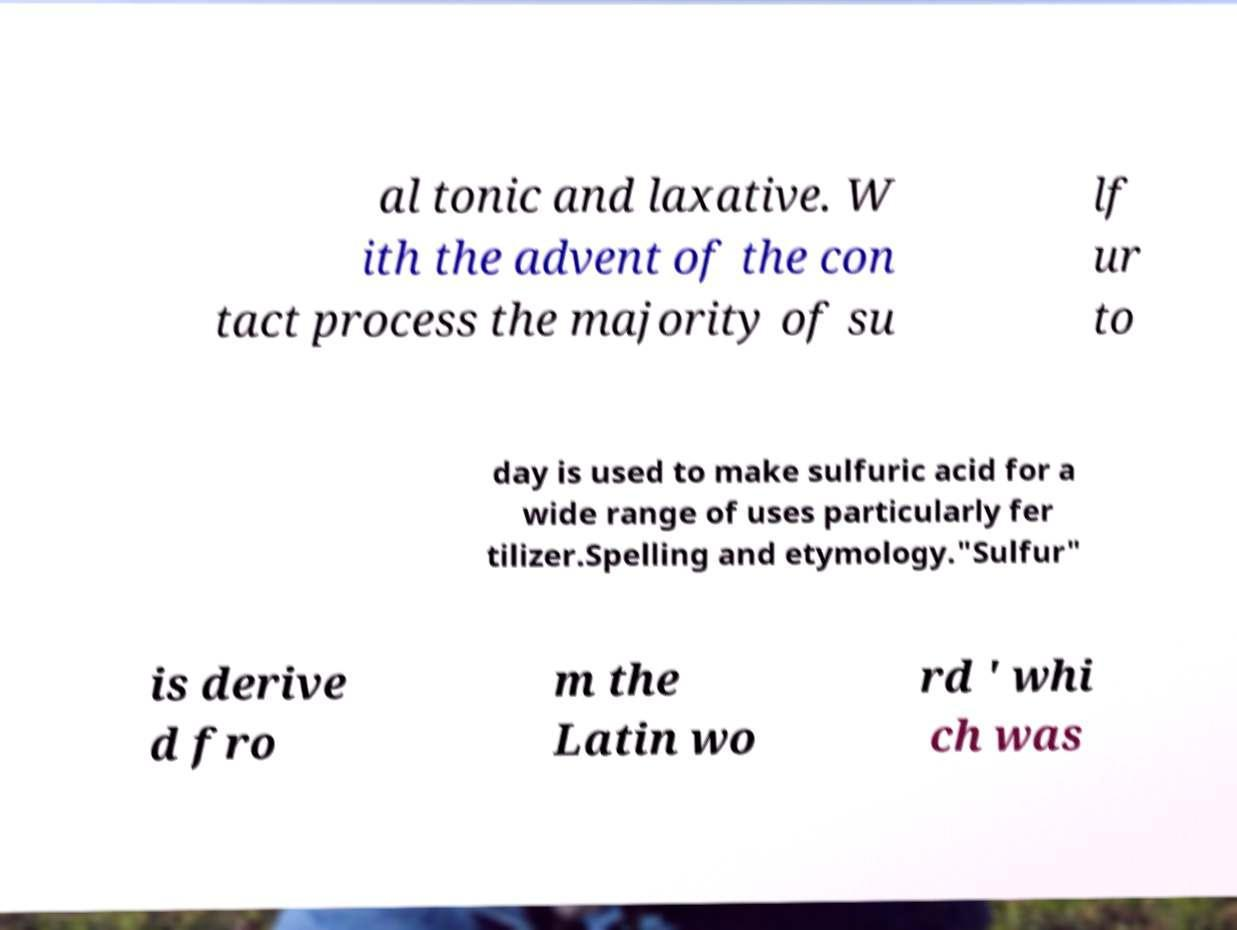Can you accurately transcribe the text from the provided image for me? al tonic and laxative. W ith the advent of the con tact process the majority of su lf ur to day is used to make sulfuric acid for a wide range of uses particularly fer tilizer.Spelling and etymology."Sulfur" is derive d fro m the Latin wo rd ' whi ch was 